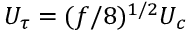<formula> <loc_0><loc_0><loc_500><loc_500>U _ { \tau } = ( f / 8 ) ^ { 1 / 2 } U _ { c }</formula> 